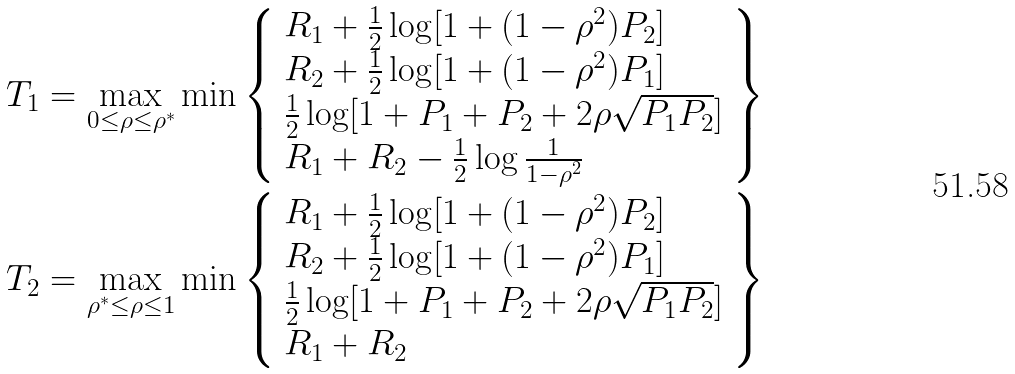<formula> <loc_0><loc_0><loc_500><loc_500>T _ { 1 } & = \max _ { 0 \leq \rho \leq \rho ^ { * } } \min \left \{ \begin{array} { l } R _ { 1 } + \frac { 1 } { 2 } \log [ 1 + ( 1 - \rho ^ { 2 } ) P _ { 2 } ] \\ R _ { 2 } + \frac { 1 } { 2 } \log [ 1 + ( 1 - \rho ^ { 2 } ) P _ { 1 } ] \\ \frac { 1 } { 2 } \log [ 1 + P _ { 1 } + P _ { 2 } + 2 \rho \sqrt { P _ { 1 } P _ { 2 } } ] \\ R _ { 1 } + R _ { 2 } - \frac { 1 } { 2 } \log \frac { 1 } { 1 - \rho ^ { 2 } } \end{array} \right \} \\ T _ { 2 } & = \max _ { \rho ^ { * } \leq \rho \leq 1 } \min \left \{ \begin{array} { l } R _ { 1 } + \frac { 1 } { 2 } \log [ 1 + ( 1 - \rho ^ { 2 } ) P _ { 2 } ] \\ R _ { 2 } + \frac { 1 } { 2 } \log [ 1 + ( 1 - \rho ^ { 2 } ) P _ { 1 } ] \\ \frac { 1 } { 2 } \log [ 1 + P _ { 1 } + P _ { 2 } + 2 \rho \sqrt { P _ { 1 } P _ { 2 } } ] \\ R _ { 1 } + R _ { 2 } \end{array} \right \}</formula> 